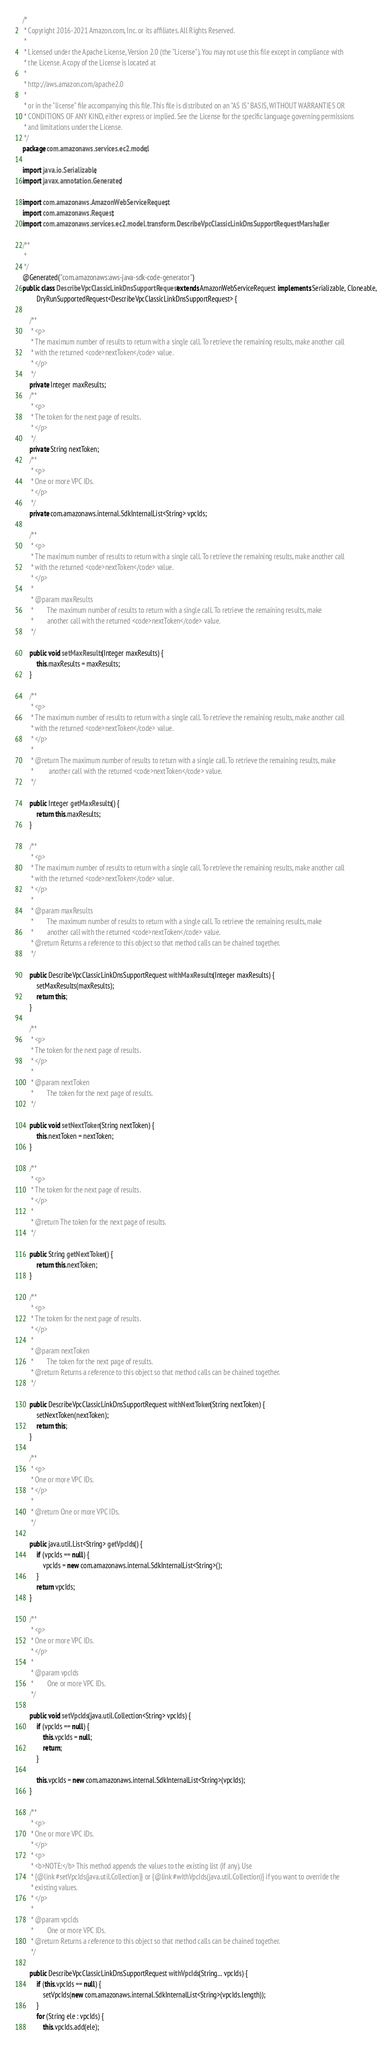<code> <loc_0><loc_0><loc_500><loc_500><_Java_>/*
 * Copyright 2016-2021 Amazon.com, Inc. or its affiliates. All Rights Reserved.
 * 
 * Licensed under the Apache License, Version 2.0 (the "License"). You may not use this file except in compliance with
 * the License. A copy of the License is located at
 * 
 * http://aws.amazon.com/apache2.0
 * 
 * or in the "license" file accompanying this file. This file is distributed on an "AS IS" BASIS, WITHOUT WARRANTIES OR
 * CONDITIONS OF ANY KIND, either express or implied. See the License for the specific language governing permissions
 * and limitations under the License.
 */
package com.amazonaws.services.ec2.model;

import java.io.Serializable;
import javax.annotation.Generated;

import com.amazonaws.AmazonWebServiceRequest;
import com.amazonaws.Request;
import com.amazonaws.services.ec2.model.transform.DescribeVpcClassicLinkDnsSupportRequestMarshaller;

/**
 * 
 */
@Generated("com.amazonaws:aws-java-sdk-code-generator")
public class DescribeVpcClassicLinkDnsSupportRequest extends AmazonWebServiceRequest implements Serializable, Cloneable,
        DryRunSupportedRequest<DescribeVpcClassicLinkDnsSupportRequest> {

    /**
     * <p>
     * The maximum number of results to return with a single call. To retrieve the remaining results, make another call
     * with the returned <code>nextToken</code> value.
     * </p>
     */
    private Integer maxResults;
    /**
     * <p>
     * The token for the next page of results.
     * </p>
     */
    private String nextToken;
    /**
     * <p>
     * One or more VPC IDs.
     * </p>
     */
    private com.amazonaws.internal.SdkInternalList<String> vpcIds;

    /**
     * <p>
     * The maximum number of results to return with a single call. To retrieve the remaining results, make another call
     * with the returned <code>nextToken</code> value.
     * </p>
     * 
     * @param maxResults
     *        The maximum number of results to return with a single call. To retrieve the remaining results, make
     *        another call with the returned <code>nextToken</code> value.
     */

    public void setMaxResults(Integer maxResults) {
        this.maxResults = maxResults;
    }

    /**
     * <p>
     * The maximum number of results to return with a single call. To retrieve the remaining results, make another call
     * with the returned <code>nextToken</code> value.
     * </p>
     * 
     * @return The maximum number of results to return with a single call. To retrieve the remaining results, make
     *         another call with the returned <code>nextToken</code> value.
     */

    public Integer getMaxResults() {
        return this.maxResults;
    }

    /**
     * <p>
     * The maximum number of results to return with a single call. To retrieve the remaining results, make another call
     * with the returned <code>nextToken</code> value.
     * </p>
     * 
     * @param maxResults
     *        The maximum number of results to return with a single call. To retrieve the remaining results, make
     *        another call with the returned <code>nextToken</code> value.
     * @return Returns a reference to this object so that method calls can be chained together.
     */

    public DescribeVpcClassicLinkDnsSupportRequest withMaxResults(Integer maxResults) {
        setMaxResults(maxResults);
        return this;
    }

    /**
     * <p>
     * The token for the next page of results.
     * </p>
     * 
     * @param nextToken
     *        The token for the next page of results.
     */

    public void setNextToken(String nextToken) {
        this.nextToken = nextToken;
    }

    /**
     * <p>
     * The token for the next page of results.
     * </p>
     * 
     * @return The token for the next page of results.
     */

    public String getNextToken() {
        return this.nextToken;
    }

    /**
     * <p>
     * The token for the next page of results.
     * </p>
     * 
     * @param nextToken
     *        The token for the next page of results.
     * @return Returns a reference to this object so that method calls can be chained together.
     */

    public DescribeVpcClassicLinkDnsSupportRequest withNextToken(String nextToken) {
        setNextToken(nextToken);
        return this;
    }

    /**
     * <p>
     * One or more VPC IDs.
     * </p>
     * 
     * @return One or more VPC IDs.
     */

    public java.util.List<String> getVpcIds() {
        if (vpcIds == null) {
            vpcIds = new com.amazonaws.internal.SdkInternalList<String>();
        }
        return vpcIds;
    }

    /**
     * <p>
     * One or more VPC IDs.
     * </p>
     * 
     * @param vpcIds
     *        One or more VPC IDs.
     */

    public void setVpcIds(java.util.Collection<String> vpcIds) {
        if (vpcIds == null) {
            this.vpcIds = null;
            return;
        }

        this.vpcIds = new com.amazonaws.internal.SdkInternalList<String>(vpcIds);
    }

    /**
     * <p>
     * One or more VPC IDs.
     * </p>
     * <p>
     * <b>NOTE:</b> This method appends the values to the existing list (if any). Use
     * {@link #setVpcIds(java.util.Collection)} or {@link #withVpcIds(java.util.Collection)} if you want to override the
     * existing values.
     * </p>
     * 
     * @param vpcIds
     *        One or more VPC IDs.
     * @return Returns a reference to this object so that method calls can be chained together.
     */

    public DescribeVpcClassicLinkDnsSupportRequest withVpcIds(String... vpcIds) {
        if (this.vpcIds == null) {
            setVpcIds(new com.amazonaws.internal.SdkInternalList<String>(vpcIds.length));
        }
        for (String ele : vpcIds) {
            this.vpcIds.add(ele);</code> 